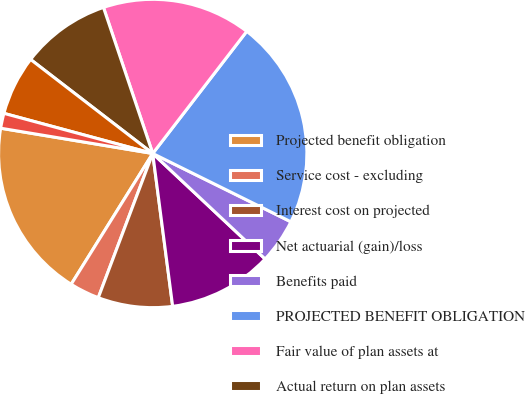Convert chart to OTSL. <chart><loc_0><loc_0><loc_500><loc_500><pie_chart><fcel>Projected benefit obligation<fcel>Service cost - excluding<fcel>Interest cost on projected<fcel>Net actuarial (gain)/loss<fcel>Benefits paid<fcel>PROJECTED BENEFIT OBLIGATION<fcel>Fair value of plan assets at<fcel>Actual return on plan assets<fcel>Employer contributions<fcel>Administrative expenses<nl><fcel>18.75%<fcel>3.13%<fcel>7.81%<fcel>10.94%<fcel>4.69%<fcel>21.87%<fcel>15.62%<fcel>9.38%<fcel>6.25%<fcel>1.57%<nl></chart> 